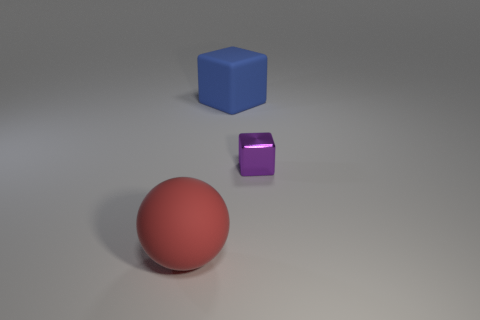Add 1 big blue objects. How many objects exist? 4 Subtract all balls. How many objects are left? 2 Add 3 red matte balls. How many red matte balls are left? 4 Add 3 gray spheres. How many gray spheres exist? 3 Subtract 1 red balls. How many objects are left? 2 Subtract all large purple metal blocks. Subtract all red rubber balls. How many objects are left? 2 